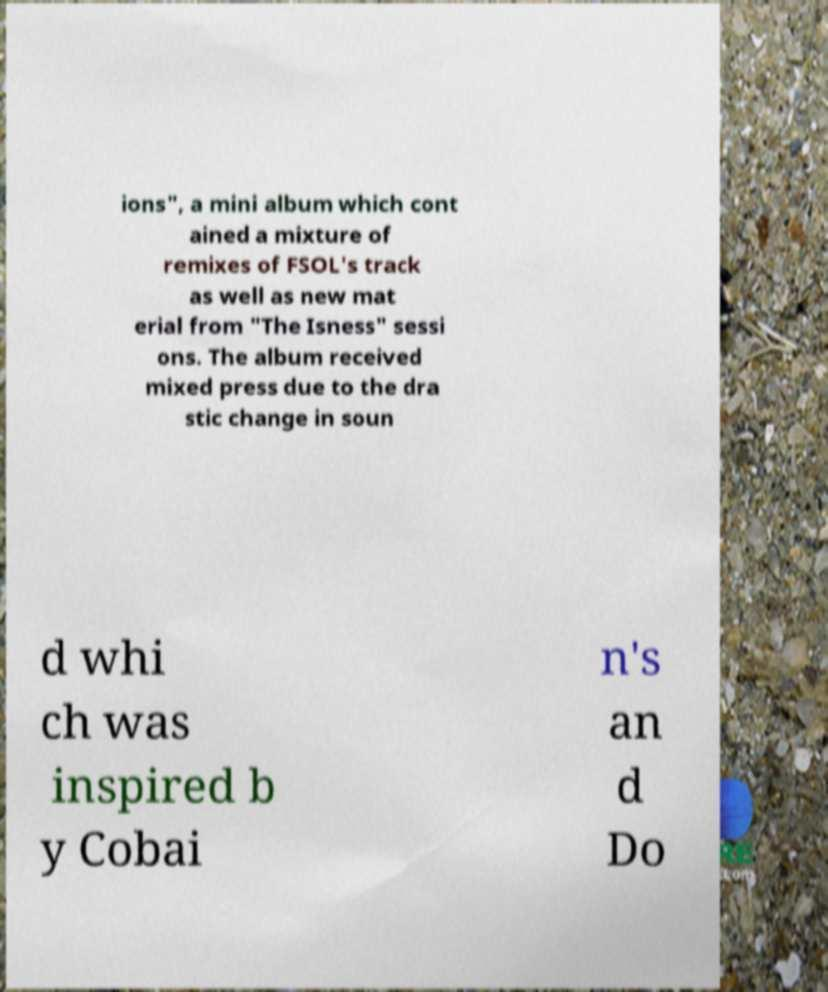There's text embedded in this image that I need extracted. Can you transcribe it verbatim? ions", a mini album which cont ained a mixture of remixes of FSOL's track as well as new mat erial from "The Isness" sessi ons. The album received mixed press due to the dra stic change in soun d whi ch was inspired b y Cobai n's an d Do 